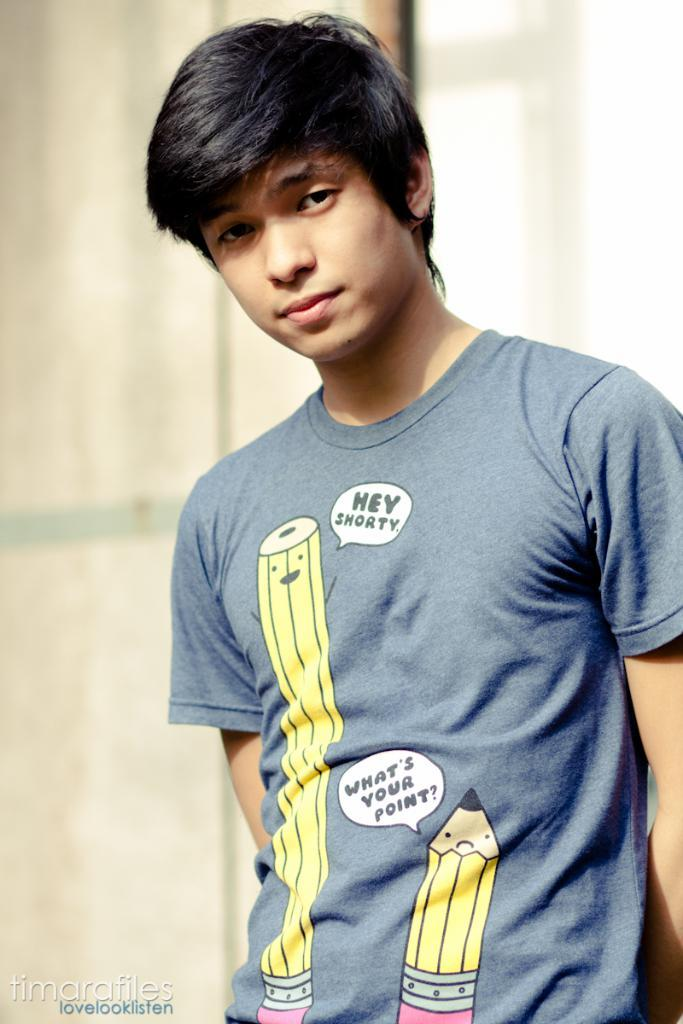Provide a one-sentence caption for the provided image. A boy is wearing a blue shirt with pictures of two pencils and one is saying Hey Shorty to the shorter one. 